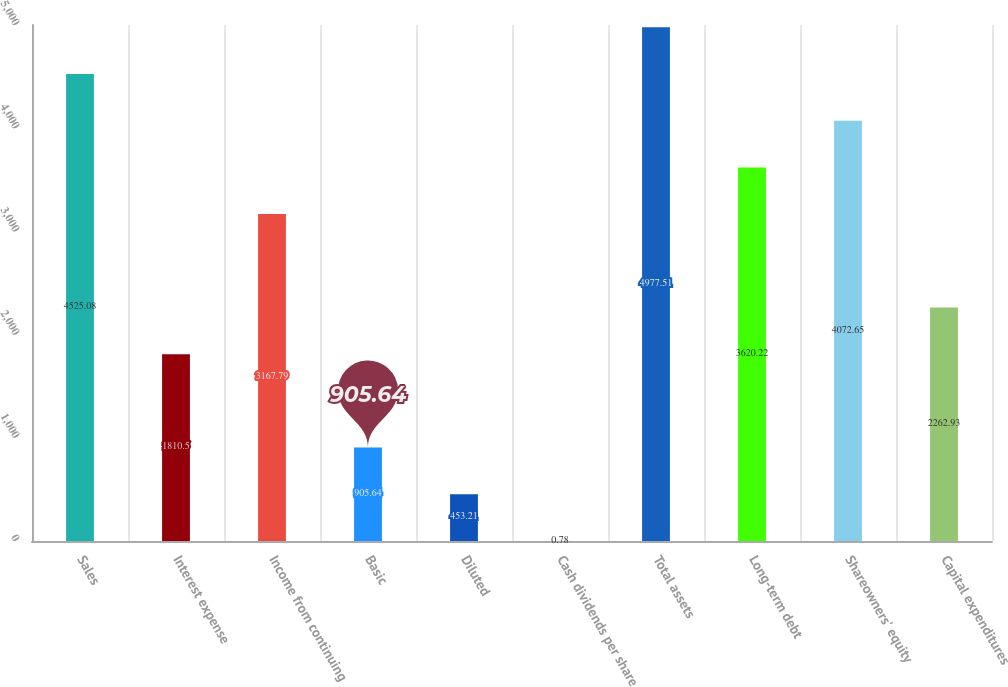Convert chart to OTSL. <chart><loc_0><loc_0><loc_500><loc_500><bar_chart><fcel>Sales<fcel>Interest expense<fcel>Income from continuing<fcel>Basic<fcel>Diluted<fcel>Cash dividends per share<fcel>Total assets<fcel>Long-term debt<fcel>Shareowners' equity<fcel>Capital expenditures<nl><fcel>4525.08<fcel>1810.5<fcel>3167.79<fcel>905.64<fcel>453.21<fcel>0.78<fcel>4977.51<fcel>3620.22<fcel>4072.65<fcel>2262.93<nl></chart> 